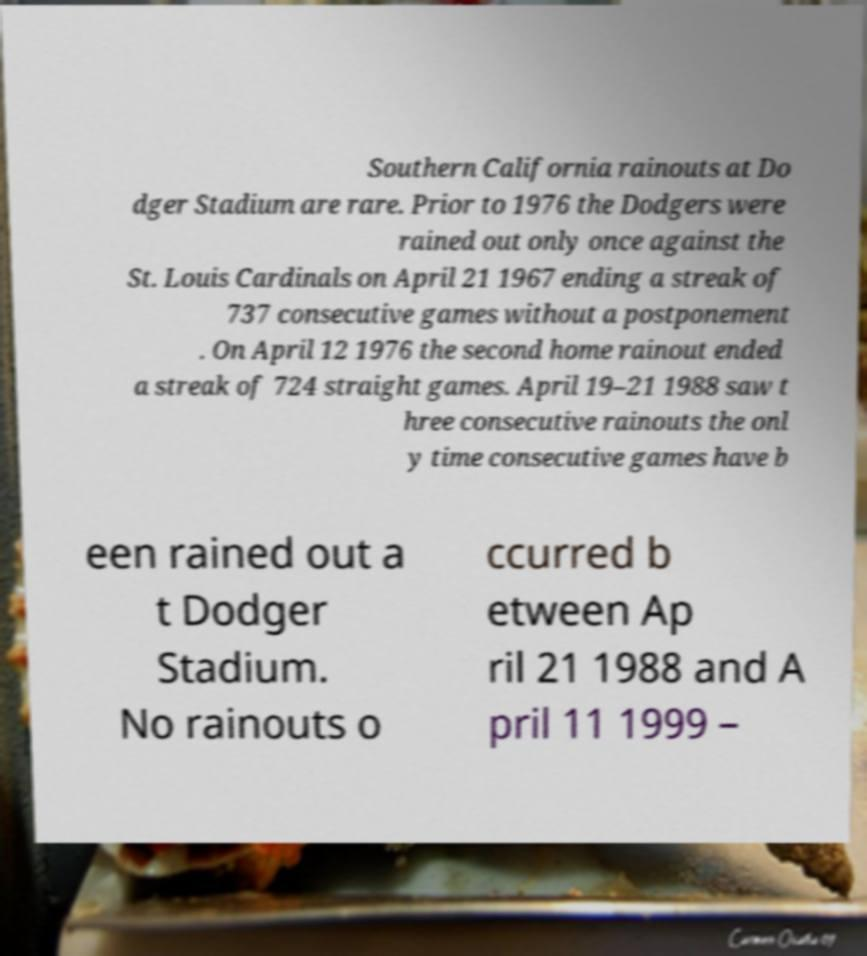Could you extract and type out the text from this image? Southern California rainouts at Do dger Stadium are rare. Prior to 1976 the Dodgers were rained out only once against the St. Louis Cardinals on April 21 1967 ending a streak of 737 consecutive games without a postponement . On April 12 1976 the second home rainout ended a streak of 724 straight games. April 19–21 1988 saw t hree consecutive rainouts the onl y time consecutive games have b een rained out a t Dodger Stadium. No rainouts o ccurred b etween Ap ril 21 1988 and A pril 11 1999 – 